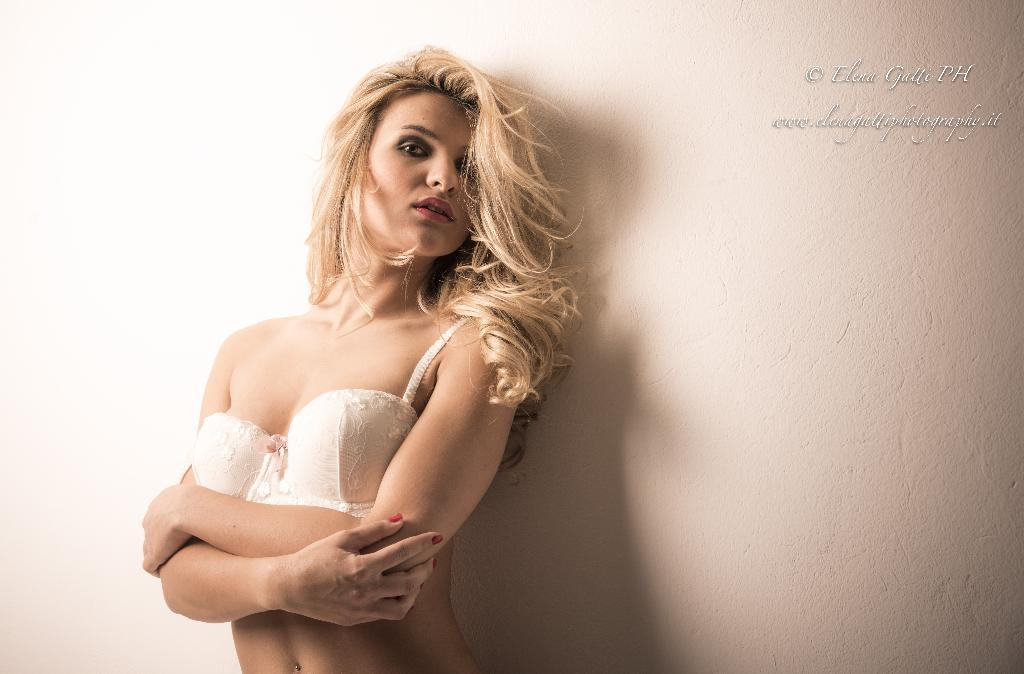What is the main subject of the image? There is a person in the image. Can you describe the person's attire? The person is wearing a dress. What color is the background of the image? The background of the image is cream-colored. What type of circle can be seen on the canvas in the image? There is no circle or canvas present in the image; it features a person wearing a dress against a cream-colored background. 